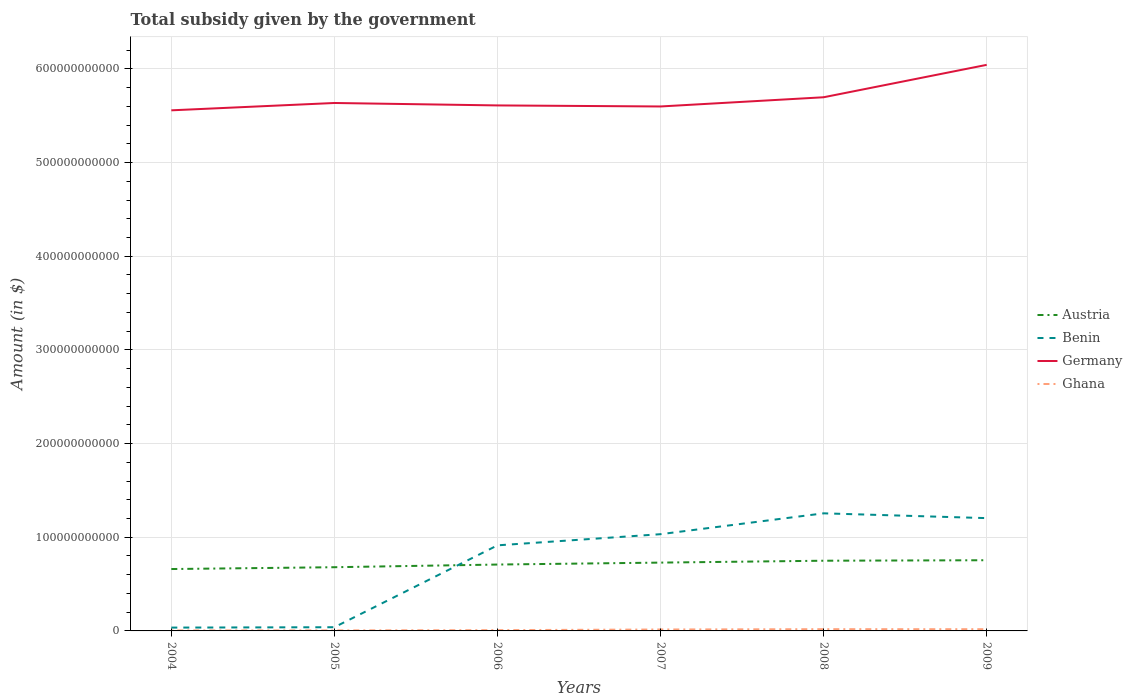How many different coloured lines are there?
Provide a short and direct response. 4. Does the line corresponding to Benin intersect with the line corresponding to Ghana?
Your response must be concise. No. Across all years, what is the maximum total revenue collected by the government in Austria?
Provide a short and direct response. 6.61e+1. In which year was the total revenue collected by the government in Ghana maximum?
Offer a very short reply. 2004. What is the total total revenue collected by the government in Ghana in the graph?
Make the answer very short. -3.14e+08. What is the difference between the highest and the second highest total revenue collected by the government in Benin?
Ensure brevity in your answer.  1.22e+11. Is the total revenue collected by the government in Austria strictly greater than the total revenue collected by the government in Ghana over the years?
Give a very brief answer. No. How many lines are there?
Offer a terse response. 4. How many years are there in the graph?
Ensure brevity in your answer.  6. What is the difference between two consecutive major ticks on the Y-axis?
Your answer should be compact. 1.00e+11. Does the graph contain any zero values?
Ensure brevity in your answer.  No. How many legend labels are there?
Your response must be concise. 4. How are the legend labels stacked?
Your answer should be compact. Vertical. What is the title of the graph?
Give a very brief answer. Total subsidy given by the government. What is the label or title of the Y-axis?
Ensure brevity in your answer.  Amount (in $). What is the Amount (in $) of Austria in 2004?
Provide a short and direct response. 6.61e+1. What is the Amount (in $) of Benin in 2004?
Your answer should be very brief. 3.55e+09. What is the Amount (in $) in Germany in 2004?
Your response must be concise. 5.56e+11. What is the Amount (in $) in Ghana in 2004?
Your answer should be compact. 5.37e+08. What is the Amount (in $) of Austria in 2005?
Your response must be concise. 6.80e+1. What is the Amount (in $) of Benin in 2005?
Provide a succinct answer. 3.96e+09. What is the Amount (in $) of Germany in 2005?
Keep it short and to the point. 5.64e+11. What is the Amount (in $) of Ghana in 2005?
Your answer should be very brief. 5.64e+08. What is the Amount (in $) in Austria in 2006?
Provide a short and direct response. 7.09e+1. What is the Amount (in $) of Benin in 2006?
Your response must be concise. 9.14e+1. What is the Amount (in $) of Germany in 2006?
Offer a terse response. 5.61e+11. What is the Amount (in $) of Ghana in 2006?
Keep it short and to the point. 8.37e+08. What is the Amount (in $) in Austria in 2007?
Provide a short and direct response. 7.29e+1. What is the Amount (in $) of Benin in 2007?
Ensure brevity in your answer.  1.03e+11. What is the Amount (in $) of Germany in 2007?
Your answer should be very brief. 5.60e+11. What is the Amount (in $) in Ghana in 2007?
Your answer should be compact. 1.53e+09. What is the Amount (in $) of Austria in 2008?
Offer a terse response. 7.49e+1. What is the Amount (in $) of Benin in 2008?
Provide a succinct answer. 1.26e+11. What is the Amount (in $) of Germany in 2008?
Offer a terse response. 5.70e+11. What is the Amount (in $) in Ghana in 2008?
Offer a very short reply. 1.87e+09. What is the Amount (in $) of Austria in 2009?
Provide a short and direct response. 7.55e+1. What is the Amount (in $) in Benin in 2009?
Your answer should be compact. 1.20e+11. What is the Amount (in $) in Germany in 2009?
Ensure brevity in your answer.  6.04e+11. What is the Amount (in $) of Ghana in 2009?
Give a very brief answer. 1.84e+09. Across all years, what is the maximum Amount (in $) in Austria?
Your response must be concise. 7.55e+1. Across all years, what is the maximum Amount (in $) of Benin?
Provide a short and direct response. 1.26e+11. Across all years, what is the maximum Amount (in $) in Germany?
Offer a terse response. 6.04e+11. Across all years, what is the maximum Amount (in $) in Ghana?
Give a very brief answer. 1.87e+09. Across all years, what is the minimum Amount (in $) in Austria?
Your answer should be compact. 6.61e+1. Across all years, what is the minimum Amount (in $) of Benin?
Keep it short and to the point. 3.55e+09. Across all years, what is the minimum Amount (in $) in Germany?
Give a very brief answer. 5.56e+11. Across all years, what is the minimum Amount (in $) in Ghana?
Keep it short and to the point. 5.37e+08. What is the total Amount (in $) in Austria in the graph?
Provide a short and direct response. 4.28e+11. What is the total Amount (in $) in Benin in the graph?
Provide a short and direct response. 4.48e+11. What is the total Amount (in $) in Germany in the graph?
Provide a succinct answer. 3.41e+12. What is the total Amount (in $) in Ghana in the graph?
Offer a terse response. 7.18e+09. What is the difference between the Amount (in $) of Austria in 2004 and that in 2005?
Provide a succinct answer. -1.95e+09. What is the difference between the Amount (in $) of Benin in 2004 and that in 2005?
Give a very brief answer. -4.04e+08. What is the difference between the Amount (in $) in Germany in 2004 and that in 2005?
Give a very brief answer. -7.84e+09. What is the difference between the Amount (in $) of Ghana in 2004 and that in 2005?
Make the answer very short. -2.71e+07. What is the difference between the Amount (in $) in Austria in 2004 and that in 2006?
Your answer should be very brief. -4.79e+09. What is the difference between the Amount (in $) of Benin in 2004 and that in 2006?
Ensure brevity in your answer.  -8.78e+1. What is the difference between the Amount (in $) in Germany in 2004 and that in 2006?
Keep it short and to the point. -5.24e+09. What is the difference between the Amount (in $) in Ghana in 2004 and that in 2006?
Make the answer very short. -3.00e+08. What is the difference between the Amount (in $) in Austria in 2004 and that in 2007?
Give a very brief answer. -6.87e+09. What is the difference between the Amount (in $) of Benin in 2004 and that in 2007?
Offer a very short reply. -9.97e+1. What is the difference between the Amount (in $) in Germany in 2004 and that in 2007?
Provide a succinct answer. -4.12e+09. What is the difference between the Amount (in $) of Ghana in 2004 and that in 2007?
Your response must be concise. -9.92e+08. What is the difference between the Amount (in $) of Austria in 2004 and that in 2008?
Offer a very short reply. -8.87e+09. What is the difference between the Amount (in $) of Benin in 2004 and that in 2008?
Offer a very short reply. -1.22e+11. What is the difference between the Amount (in $) of Germany in 2004 and that in 2008?
Ensure brevity in your answer.  -1.40e+1. What is the difference between the Amount (in $) in Ghana in 2004 and that in 2008?
Make the answer very short. -1.33e+09. What is the difference between the Amount (in $) of Austria in 2004 and that in 2009?
Offer a very short reply. -9.40e+09. What is the difference between the Amount (in $) in Benin in 2004 and that in 2009?
Provide a short and direct response. -1.17e+11. What is the difference between the Amount (in $) in Germany in 2004 and that in 2009?
Provide a succinct answer. -4.85e+1. What is the difference between the Amount (in $) in Ghana in 2004 and that in 2009?
Your answer should be very brief. -1.31e+09. What is the difference between the Amount (in $) in Austria in 2005 and that in 2006?
Provide a succinct answer. -2.85e+09. What is the difference between the Amount (in $) of Benin in 2005 and that in 2006?
Your answer should be compact. -8.74e+1. What is the difference between the Amount (in $) in Germany in 2005 and that in 2006?
Give a very brief answer. 2.60e+09. What is the difference between the Amount (in $) of Ghana in 2005 and that in 2006?
Make the answer very short. -2.73e+08. What is the difference between the Amount (in $) of Austria in 2005 and that in 2007?
Your answer should be compact. -4.92e+09. What is the difference between the Amount (in $) in Benin in 2005 and that in 2007?
Offer a very short reply. -9.93e+1. What is the difference between the Amount (in $) in Germany in 2005 and that in 2007?
Ensure brevity in your answer.  3.72e+09. What is the difference between the Amount (in $) of Ghana in 2005 and that in 2007?
Your answer should be compact. -9.65e+08. What is the difference between the Amount (in $) in Austria in 2005 and that in 2008?
Provide a succinct answer. -6.93e+09. What is the difference between the Amount (in $) in Benin in 2005 and that in 2008?
Provide a short and direct response. -1.22e+11. What is the difference between the Amount (in $) of Germany in 2005 and that in 2008?
Provide a succinct answer. -6.11e+09. What is the difference between the Amount (in $) in Ghana in 2005 and that in 2008?
Provide a short and direct response. -1.31e+09. What is the difference between the Amount (in $) of Austria in 2005 and that in 2009?
Your response must be concise. -7.45e+09. What is the difference between the Amount (in $) in Benin in 2005 and that in 2009?
Provide a succinct answer. -1.16e+11. What is the difference between the Amount (in $) of Germany in 2005 and that in 2009?
Your answer should be compact. -4.07e+1. What is the difference between the Amount (in $) of Ghana in 2005 and that in 2009?
Your answer should be compact. -1.28e+09. What is the difference between the Amount (in $) of Austria in 2006 and that in 2007?
Ensure brevity in your answer.  -2.08e+09. What is the difference between the Amount (in $) of Benin in 2006 and that in 2007?
Keep it short and to the point. -1.19e+1. What is the difference between the Amount (in $) of Germany in 2006 and that in 2007?
Your answer should be very brief. 1.12e+09. What is the difference between the Amount (in $) in Ghana in 2006 and that in 2007?
Ensure brevity in your answer.  -6.92e+08. What is the difference between the Amount (in $) of Austria in 2006 and that in 2008?
Make the answer very short. -4.08e+09. What is the difference between the Amount (in $) in Benin in 2006 and that in 2008?
Your response must be concise. -3.42e+1. What is the difference between the Amount (in $) in Germany in 2006 and that in 2008?
Give a very brief answer. -8.71e+09. What is the difference between the Amount (in $) in Ghana in 2006 and that in 2008?
Provide a succinct answer. -1.03e+09. What is the difference between the Amount (in $) in Austria in 2006 and that in 2009?
Offer a terse response. -4.61e+09. What is the difference between the Amount (in $) of Benin in 2006 and that in 2009?
Offer a terse response. -2.91e+1. What is the difference between the Amount (in $) in Germany in 2006 and that in 2009?
Ensure brevity in your answer.  -4.33e+1. What is the difference between the Amount (in $) of Ghana in 2006 and that in 2009?
Provide a succinct answer. -1.01e+09. What is the difference between the Amount (in $) of Austria in 2007 and that in 2008?
Ensure brevity in your answer.  -2.01e+09. What is the difference between the Amount (in $) in Benin in 2007 and that in 2008?
Offer a terse response. -2.23e+1. What is the difference between the Amount (in $) in Germany in 2007 and that in 2008?
Ensure brevity in your answer.  -9.83e+09. What is the difference between the Amount (in $) of Ghana in 2007 and that in 2008?
Provide a succinct answer. -3.43e+08. What is the difference between the Amount (in $) of Austria in 2007 and that in 2009?
Your response must be concise. -2.53e+09. What is the difference between the Amount (in $) in Benin in 2007 and that in 2009?
Provide a short and direct response. -1.71e+1. What is the difference between the Amount (in $) in Germany in 2007 and that in 2009?
Provide a short and direct response. -4.44e+1. What is the difference between the Amount (in $) of Ghana in 2007 and that in 2009?
Your answer should be very brief. -3.14e+08. What is the difference between the Amount (in $) in Austria in 2008 and that in 2009?
Your response must be concise. -5.25e+08. What is the difference between the Amount (in $) of Benin in 2008 and that in 2009?
Your answer should be compact. 5.12e+09. What is the difference between the Amount (in $) in Germany in 2008 and that in 2009?
Your answer should be very brief. -3.46e+1. What is the difference between the Amount (in $) in Ghana in 2008 and that in 2009?
Your answer should be compact. 2.92e+07. What is the difference between the Amount (in $) in Austria in 2004 and the Amount (in $) in Benin in 2005?
Your answer should be compact. 6.21e+1. What is the difference between the Amount (in $) in Austria in 2004 and the Amount (in $) in Germany in 2005?
Provide a succinct answer. -4.98e+11. What is the difference between the Amount (in $) of Austria in 2004 and the Amount (in $) of Ghana in 2005?
Offer a very short reply. 6.55e+1. What is the difference between the Amount (in $) in Benin in 2004 and the Amount (in $) in Germany in 2005?
Make the answer very short. -5.60e+11. What is the difference between the Amount (in $) of Benin in 2004 and the Amount (in $) of Ghana in 2005?
Ensure brevity in your answer.  2.99e+09. What is the difference between the Amount (in $) in Germany in 2004 and the Amount (in $) in Ghana in 2005?
Make the answer very short. 5.55e+11. What is the difference between the Amount (in $) in Austria in 2004 and the Amount (in $) in Benin in 2006?
Provide a short and direct response. -2.53e+1. What is the difference between the Amount (in $) of Austria in 2004 and the Amount (in $) of Germany in 2006?
Ensure brevity in your answer.  -4.95e+11. What is the difference between the Amount (in $) in Austria in 2004 and the Amount (in $) in Ghana in 2006?
Your response must be concise. 6.52e+1. What is the difference between the Amount (in $) in Benin in 2004 and the Amount (in $) in Germany in 2006?
Your response must be concise. -5.57e+11. What is the difference between the Amount (in $) in Benin in 2004 and the Amount (in $) in Ghana in 2006?
Offer a terse response. 2.72e+09. What is the difference between the Amount (in $) in Germany in 2004 and the Amount (in $) in Ghana in 2006?
Offer a terse response. 5.55e+11. What is the difference between the Amount (in $) in Austria in 2004 and the Amount (in $) in Benin in 2007?
Make the answer very short. -3.72e+1. What is the difference between the Amount (in $) in Austria in 2004 and the Amount (in $) in Germany in 2007?
Offer a terse response. -4.94e+11. What is the difference between the Amount (in $) of Austria in 2004 and the Amount (in $) of Ghana in 2007?
Give a very brief answer. 6.45e+1. What is the difference between the Amount (in $) in Benin in 2004 and the Amount (in $) in Germany in 2007?
Give a very brief answer. -5.56e+11. What is the difference between the Amount (in $) in Benin in 2004 and the Amount (in $) in Ghana in 2007?
Keep it short and to the point. 2.02e+09. What is the difference between the Amount (in $) of Germany in 2004 and the Amount (in $) of Ghana in 2007?
Give a very brief answer. 5.54e+11. What is the difference between the Amount (in $) in Austria in 2004 and the Amount (in $) in Benin in 2008?
Your answer should be compact. -5.95e+1. What is the difference between the Amount (in $) in Austria in 2004 and the Amount (in $) in Germany in 2008?
Keep it short and to the point. -5.04e+11. What is the difference between the Amount (in $) in Austria in 2004 and the Amount (in $) in Ghana in 2008?
Keep it short and to the point. 6.42e+1. What is the difference between the Amount (in $) in Benin in 2004 and the Amount (in $) in Germany in 2008?
Offer a terse response. -5.66e+11. What is the difference between the Amount (in $) of Benin in 2004 and the Amount (in $) of Ghana in 2008?
Provide a succinct answer. 1.68e+09. What is the difference between the Amount (in $) in Germany in 2004 and the Amount (in $) in Ghana in 2008?
Give a very brief answer. 5.54e+11. What is the difference between the Amount (in $) of Austria in 2004 and the Amount (in $) of Benin in 2009?
Your answer should be very brief. -5.43e+1. What is the difference between the Amount (in $) in Austria in 2004 and the Amount (in $) in Germany in 2009?
Ensure brevity in your answer.  -5.38e+11. What is the difference between the Amount (in $) in Austria in 2004 and the Amount (in $) in Ghana in 2009?
Your response must be concise. 6.42e+1. What is the difference between the Amount (in $) of Benin in 2004 and the Amount (in $) of Germany in 2009?
Your answer should be compact. -6.01e+11. What is the difference between the Amount (in $) in Benin in 2004 and the Amount (in $) in Ghana in 2009?
Provide a short and direct response. 1.71e+09. What is the difference between the Amount (in $) of Germany in 2004 and the Amount (in $) of Ghana in 2009?
Provide a succinct answer. 5.54e+11. What is the difference between the Amount (in $) in Austria in 2005 and the Amount (in $) in Benin in 2006?
Your answer should be compact. -2.33e+1. What is the difference between the Amount (in $) of Austria in 2005 and the Amount (in $) of Germany in 2006?
Ensure brevity in your answer.  -4.93e+11. What is the difference between the Amount (in $) in Austria in 2005 and the Amount (in $) in Ghana in 2006?
Your answer should be compact. 6.72e+1. What is the difference between the Amount (in $) in Benin in 2005 and the Amount (in $) in Germany in 2006?
Make the answer very short. -5.57e+11. What is the difference between the Amount (in $) of Benin in 2005 and the Amount (in $) of Ghana in 2006?
Your answer should be very brief. 3.12e+09. What is the difference between the Amount (in $) in Germany in 2005 and the Amount (in $) in Ghana in 2006?
Provide a succinct answer. 5.63e+11. What is the difference between the Amount (in $) of Austria in 2005 and the Amount (in $) of Benin in 2007?
Give a very brief answer. -3.53e+1. What is the difference between the Amount (in $) of Austria in 2005 and the Amount (in $) of Germany in 2007?
Offer a terse response. -4.92e+11. What is the difference between the Amount (in $) of Austria in 2005 and the Amount (in $) of Ghana in 2007?
Ensure brevity in your answer.  6.65e+1. What is the difference between the Amount (in $) in Benin in 2005 and the Amount (in $) in Germany in 2007?
Provide a succinct answer. -5.56e+11. What is the difference between the Amount (in $) in Benin in 2005 and the Amount (in $) in Ghana in 2007?
Offer a terse response. 2.43e+09. What is the difference between the Amount (in $) in Germany in 2005 and the Amount (in $) in Ghana in 2007?
Offer a terse response. 5.62e+11. What is the difference between the Amount (in $) in Austria in 2005 and the Amount (in $) in Benin in 2008?
Ensure brevity in your answer.  -5.75e+1. What is the difference between the Amount (in $) of Austria in 2005 and the Amount (in $) of Germany in 2008?
Provide a short and direct response. -5.02e+11. What is the difference between the Amount (in $) of Austria in 2005 and the Amount (in $) of Ghana in 2008?
Ensure brevity in your answer.  6.61e+1. What is the difference between the Amount (in $) in Benin in 2005 and the Amount (in $) in Germany in 2008?
Your answer should be very brief. -5.66e+11. What is the difference between the Amount (in $) in Benin in 2005 and the Amount (in $) in Ghana in 2008?
Offer a terse response. 2.08e+09. What is the difference between the Amount (in $) in Germany in 2005 and the Amount (in $) in Ghana in 2008?
Give a very brief answer. 5.62e+11. What is the difference between the Amount (in $) of Austria in 2005 and the Amount (in $) of Benin in 2009?
Your answer should be compact. -5.24e+1. What is the difference between the Amount (in $) of Austria in 2005 and the Amount (in $) of Germany in 2009?
Offer a terse response. -5.36e+11. What is the difference between the Amount (in $) of Austria in 2005 and the Amount (in $) of Ghana in 2009?
Your answer should be compact. 6.62e+1. What is the difference between the Amount (in $) of Benin in 2005 and the Amount (in $) of Germany in 2009?
Provide a short and direct response. -6.00e+11. What is the difference between the Amount (in $) of Benin in 2005 and the Amount (in $) of Ghana in 2009?
Give a very brief answer. 2.11e+09. What is the difference between the Amount (in $) in Germany in 2005 and the Amount (in $) in Ghana in 2009?
Provide a succinct answer. 5.62e+11. What is the difference between the Amount (in $) of Austria in 2006 and the Amount (in $) of Benin in 2007?
Make the answer very short. -3.24e+1. What is the difference between the Amount (in $) in Austria in 2006 and the Amount (in $) in Germany in 2007?
Offer a terse response. -4.89e+11. What is the difference between the Amount (in $) in Austria in 2006 and the Amount (in $) in Ghana in 2007?
Your response must be concise. 6.93e+1. What is the difference between the Amount (in $) in Benin in 2006 and the Amount (in $) in Germany in 2007?
Provide a short and direct response. -4.68e+11. What is the difference between the Amount (in $) in Benin in 2006 and the Amount (in $) in Ghana in 2007?
Make the answer very short. 8.98e+1. What is the difference between the Amount (in $) of Germany in 2006 and the Amount (in $) of Ghana in 2007?
Offer a terse response. 5.59e+11. What is the difference between the Amount (in $) of Austria in 2006 and the Amount (in $) of Benin in 2008?
Your response must be concise. -5.47e+1. What is the difference between the Amount (in $) of Austria in 2006 and the Amount (in $) of Germany in 2008?
Your answer should be very brief. -4.99e+11. What is the difference between the Amount (in $) of Austria in 2006 and the Amount (in $) of Ghana in 2008?
Your response must be concise. 6.90e+1. What is the difference between the Amount (in $) of Benin in 2006 and the Amount (in $) of Germany in 2008?
Offer a terse response. -4.78e+11. What is the difference between the Amount (in $) of Benin in 2006 and the Amount (in $) of Ghana in 2008?
Provide a succinct answer. 8.95e+1. What is the difference between the Amount (in $) in Germany in 2006 and the Amount (in $) in Ghana in 2008?
Provide a succinct answer. 5.59e+11. What is the difference between the Amount (in $) of Austria in 2006 and the Amount (in $) of Benin in 2009?
Your answer should be compact. -4.96e+1. What is the difference between the Amount (in $) in Austria in 2006 and the Amount (in $) in Germany in 2009?
Provide a short and direct response. -5.33e+11. What is the difference between the Amount (in $) of Austria in 2006 and the Amount (in $) of Ghana in 2009?
Give a very brief answer. 6.90e+1. What is the difference between the Amount (in $) of Benin in 2006 and the Amount (in $) of Germany in 2009?
Offer a terse response. -5.13e+11. What is the difference between the Amount (in $) in Benin in 2006 and the Amount (in $) in Ghana in 2009?
Your answer should be compact. 8.95e+1. What is the difference between the Amount (in $) in Germany in 2006 and the Amount (in $) in Ghana in 2009?
Your answer should be very brief. 5.59e+11. What is the difference between the Amount (in $) of Austria in 2007 and the Amount (in $) of Benin in 2008?
Your answer should be very brief. -5.26e+1. What is the difference between the Amount (in $) in Austria in 2007 and the Amount (in $) in Germany in 2008?
Your response must be concise. -4.97e+11. What is the difference between the Amount (in $) of Austria in 2007 and the Amount (in $) of Ghana in 2008?
Make the answer very short. 7.11e+1. What is the difference between the Amount (in $) of Benin in 2007 and the Amount (in $) of Germany in 2008?
Provide a succinct answer. -4.66e+11. What is the difference between the Amount (in $) in Benin in 2007 and the Amount (in $) in Ghana in 2008?
Give a very brief answer. 1.01e+11. What is the difference between the Amount (in $) in Germany in 2007 and the Amount (in $) in Ghana in 2008?
Offer a very short reply. 5.58e+11. What is the difference between the Amount (in $) of Austria in 2007 and the Amount (in $) of Benin in 2009?
Ensure brevity in your answer.  -4.75e+1. What is the difference between the Amount (in $) in Austria in 2007 and the Amount (in $) in Germany in 2009?
Ensure brevity in your answer.  -5.31e+11. What is the difference between the Amount (in $) of Austria in 2007 and the Amount (in $) of Ghana in 2009?
Make the answer very short. 7.11e+1. What is the difference between the Amount (in $) in Benin in 2007 and the Amount (in $) in Germany in 2009?
Provide a short and direct response. -5.01e+11. What is the difference between the Amount (in $) of Benin in 2007 and the Amount (in $) of Ghana in 2009?
Your response must be concise. 1.01e+11. What is the difference between the Amount (in $) of Germany in 2007 and the Amount (in $) of Ghana in 2009?
Give a very brief answer. 5.58e+11. What is the difference between the Amount (in $) in Austria in 2008 and the Amount (in $) in Benin in 2009?
Ensure brevity in your answer.  -4.55e+1. What is the difference between the Amount (in $) of Austria in 2008 and the Amount (in $) of Germany in 2009?
Ensure brevity in your answer.  -5.29e+11. What is the difference between the Amount (in $) in Austria in 2008 and the Amount (in $) in Ghana in 2009?
Offer a terse response. 7.31e+1. What is the difference between the Amount (in $) in Benin in 2008 and the Amount (in $) in Germany in 2009?
Offer a very short reply. -4.79e+11. What is the difference between the Amount (in $) in Benin in 2008 and the Amount (in $) in Ghana in 2009?
Offer a terse response. 1.24e+11. What is the difference between the Amount (in $) in Germany in 2008 and the Amount (in $) in Ghana in 2009?
Provide a short and direct response. 5.68e+11. What is the average Amount (in $) of Austria per year?
Provide a short and direct response. 7.14e+1. What is the average Amount (in $) of Benin per year?
Make the answer very short. 7.47e+1. What is the average Amount (in $) in Germany per year?
Offer a terse response. 5.69e+11. What is the average Amount (in $) of Ghana per year?
Make the answer very short. 1.20e+09. In the year 2004, what is the difference between the Amount (in $) of Austria and Amount (in $) of Benin?
Provide a succinct answer. 6.25e+1. In the year 2004, what is the difference between the Amount (in $) of Austria and Amount (in $) of Germany?
Your answer should be compact. -4.90e+11. In the year 2004, what is the difference between the Amount (in $) in Austria and Amount (in $) in Ghana?
Keep it short and to the point. 6.55e+1. In the year 2004, what is the difference between the Amount (in $) of Benin and Amount (in $) of Germany?
Offer a terse response. -5.52e+11. In the year 2004, what is the difference between the Amount (in $) of Benin and Amount (in $) of Ghana?
Offer a terse response. 3.02e+09. In the year 2004, what is the difference between the Amount (in $) of Germany and Amount (in $) of Ghana?
Make the answer very short. 5.55e+11. In the year 2005, what is the difference between the Amount (in $) in Austria and Amount (in $) in Benin?
Give a very brief answer. 6.41e+1. In the year 2005, what is the difference between the Amount (in $) of Austria and Amount (in $) of Germany?
Your answer should be compact. -4.96e+11. In the year 2005, what is the difference between the Amount (in $) of Austria and Amount (in $) of Ghana?
Provide a succinct answer. 6.74e+1. In the year 2005, what is the difference between the Amount (in $) in Benin and Amount (in $) in Germany?
Your answer should be very brief. -5.60e+11. In the year 2005, what is the difference between the Amount (in $) in Benin and Amount (in $) in Ghana?
Your response must be concise. 3.39e+09. In the year 2005, what is the difference between the Amount (in $) in Germany and Amount (in $) in Ghana?
Offer a very short reply. 5.63e+11. In the year 2006, what is the difference between the Amount (in $) of Austria and Amount (in $) of Benin?
Your answer should be very brief. -2.05e+1. In the year 2006, what is the difference between the Amount (in $) in Austria and Amount (in $) in Germany?
Offer a terse response. -4.90e+11. In the year 2006, what is the difference between the Amount (in $) in Austria and Amount (in $) in Ghana?
Your response must be concise. 7.00e+1. In the year 2006, what is the difference between the Amount (in $) of Benin and Amount (in $) of Germany?
Make the answer very short. -4.70e+11. In the year 2006, what is the difference between the Amount (in $) of Benin and Amount (in $) of Ghana?
Offer a very short reply. 9.05e+1. In the year 2006, what is the difference between the Amount (in $) in Germany and Amount (in $) in Ghana?
Offer a very short reply. 5.60e+11. In the year 2007, what is the difference between the Amount (in $) of Austria and Amount (in $) of Benin?
Ensure brevity in your answer.  -3.03e+1. In the year 2007, what is the difference between the Amount (in $) in Austria and Amount (in $) in Germany?
Offer a very short reply. -4.87e+11. In the year 2007, what is the difference between the Amount (in $) in Austria and Amount (in $) in Ghana?
Make the answer very short. 7.14e+1. In the year 2007, what is the difference between the Amount (in $) of Benin and Amount (in $) of Germany?
Your response must be concise. -4.57e+11. In the year 2007, what is the difference between the Amount (in $) of Benin and Amount (in $) of Ghana?
Your answer should be very brief. 1.02e+11. In the year 2007, what is the difference between the Amount (in $) in Germany and Amount (in $) in Ghana?
Your answer should be compact. 5.58e+11. In the year 2008, what is the difference between the Amount (in $) of Austria and Amount (in $) of Benin?
Keep it short and to the point. -5.06e+1. In the year 2008, what is the difference between the Amount (in $) of Austria and Amount (in $) of Germany?
Your answer should be compact. -4.95e+11. In the year 2008, what is the difference between the Amount (in $) of Austria and Amount (in $) of Ghana?
Ensure brevity in your answer.  7.31e+1. In the year 2008, what is the difference between the Amount (in $) of Benin and Amount (in $) of Germany?
Your answer should be very brief. -4.44e+11. In the year 2008, what is the difference between the Amount (in $) in Benin and Amount (in $) in Ghana?
Your response must be concise. 1.24e+11. In the year 2008, what is the difference between the Amount (in $) in Germany and Amount (in $) in Ghana?
Make the answer very short. 5.68e+11. In the year 2009, what is the difference between the Amount (in $) in Austria and Amount (in $) in Benin?
Keep it short and to the point. -4.49e+1. In the year 2009, what is the difference between the Amount (in $) of Austria and Amount (in $) of Germany?
Your answer should be very brief. -5.29e+11. In the year 2009, what is the difference between the Amount (in $) in Austria and Amount (in $) in Ghana?
Provide a succinct answer. 7.36e+1. In the year 2009, what is the difference between the Amount (in $) in Benin and Amount (in $) in Germany?
Offer a terse response. -4.84e+11. In the year 2009, what is the difference between the Amount (in $) of Benin and Amount (in $) of Ghana?
Ensure brevity in your answer.  1.19e+11. In the year 2009, what is the difference between the Amount (in $) in Germany and Amount (in $) in Ghana?
Your answer should be very brief. 6.02e+11. What is the ratio of the Amount (in $) in Austria in 2004 to that in 2005?
Provide a short and direct response. 0.97. What is the ratio of the Amount (in $) in Benin in 2004 to that in 2005?
Your answer should be very brief. 0.9. What is the ratio of the Amount (in $) in Germany in 2004 to that in 2005?
Provide a short and direct response. 0.99. What is the ratio of the Amount (in $) in Ghana in 2004 to that in 2005?
Your answer should be very brief. 0.95. What is the ratio of the Amount (in $) of Austria in 2004 to that in 2006?
Your answer should be compact. 0.93. What is the ratio of the Amount (in $) in Benin in 2004 to that in 2006?
Your response must be concise. 0.04. What is the ratio of the Amount (in $) in Germany in 2004 to that in 2006?
Offer a terse response. 0.99. What is the ratio of the Amount (in $) in Ghana in 2004 to that in 2006?
Your answer should be very brief. 0.64. What is the ratio of the Amount (in $) in Austria in 2004 to that in 2007?
Your answer should be compact. 0.91. What is the ratio of the Amount (in $) in Benin in 2004 to that in 2007?
Your response must be concise. 0.03. What is the ratio of the Amount (in $) of Ghana in 2004 to that in 2007?
Your response must be concise. 0.35. What is the ratio of the Amount (in $) in Austria in 2004 to that in 2008?
Keep it short and to the point. 0.88. What is the ratio of the Amount (in $) in Benin in 2004 to that in 2008?
Ensure brevity in your answer.  0.03. What is the ratio of the Amount (in $) of Germany in 2004 to that in 2008?
Keep it short and to the point. 0.98. What is the ratio of the Amount (in $) of Ghana in 2004 to that in 2008?
Ensure brevity in your answer.  0.29. What is the ratio of the Amount (in $) of Austria in 2004 to that in 2009?
Provide a short and direct response. 0.88. What is the ratio of the Amount (in $) of Benin in 2004 to that in 2009?
Your answer should be very brief. 0.03. What is the ratio of the Amount (in $) in Germany in 2004 to that in 2009?
Provide a short and direct response. 0.92. What is the ratio of the Amount (in $) of Ghana in 2004 to that in 2009?
Make the answer very short. 0.29. What is the ratio of the Amount (in $) in Austria in 2005 to that in 2006?
Ensure brevity in your answer.  0.96. What is the ratio of the Amount (in $) of Benin in 2005 to that in 2006?
Provide a succinct answer. 0.04. What is the ratio of the Amount (in $) in Ghana in 2005 to that in 2006?
Provide a short and direct response. 0.67. What is the ratio of the Amount (in $) in Austria in 2005 to that in 2007?
Keep it short and to the point. 0.93. What is the ratio of the Amount (in $) of Benin in 2005 to that in 2007?
Ensure brevity in your answer.  0.04. What is the ratio of the Amount (in $) of Germany in 2005 to that in 2007?
Make the answer very short. 1.01. What is the ratio of the Amount (in $) of Ghana in 2005 to that in 2007?
Give a very brief answer. 0.37. What is the ratio of the Amount (in $) of Austria in 2005 to that in 2008?
Offer a terse response. 0.91. What is the ratio of the Amount (in $) of Benin in 2005 to that in 2008?
Offer a terse response. 0.03. What is the ratio of the Amount (in $) of Germany in 2005 to that in 2008?
Your answer should be very brief. 0.99. What is the ratio of the Amount (in $) in Ghana in 2005 to that in 2008?
Offer a very short reply. 0.3. What is the ratio of the Amount (in $) in Austria in 2005 to that in 2009?
Your answer should be compact. 0.9. What is the ratio of the Amount (in $) in Benin in 2005 to that in 2009?
Your response must be concise. 0.03. What is the ratio of the Amount (in $) in Germany in 2005 to that in 2009?
Ensure brevity in your answer.  0.93. What is the ratio of the Amount (in $) of Ghana in 2005 to that in 2009?
Provide a short and direct response. 0.31. What is the ratio of the Amount (in $) of Austria in 2006 to that in 2007?
Make the answer very short. 0.97. What is the ratio of the Amount (in $) of Benin in 2006 to that in 2007?
Ensure brevity in your answer.  0.88. What is the ratio of the Amount (in $) in Germany in 2006 to that in 2007?
Your answer should be compact. 1. What is the ratio of the Amount (in $) of Ghana in 2006 to that in 2007?
Offer a very short reply. 0.55. What is the ratio of the Amount (in $) in Austria in 2006 to that in 2008?
Your answer should be compact. 0.95. What is the ratio of the Amount (in $) in Benin in 2006 to that in 2008?
Provide a succinct answer. 0.73. What is the ratio of the Amount (in $) of Germany in 2006 to that in 2008?
Give a very brief answer. 0.98. What is the ratio of the Amount (in $) of Ghana in 2006 to that in 2008?
Your response must be concise. 0.45. What is the ratio of the Amount (in $) of Austria in 2006 to that in 2009?
Provide a succinct answer. 0.94. What is the ratio of the Amount (in $) in Benin in 2006 to that in 2009?
Offer a terse response. 0.76. What is the ratio of the Amount (in $) in Germany in 2006 to that in 2009?
Offer a very short reply. 0.93. What is the ratio of the Amount (in $) in Ghana in 2006 to that in 2009?
Offer a terse response. 0.45. What is the ratio of the Amount (in $) in Austria in 2007 to that in 2008?
Your answer should be very brief. 0.97. What is the ratio of the Amount (in $) in Benin in 2007 to that in 2008?
Your response must be concise. 0.82. What is the ratio of the Amount (in $) in Germany in 2007 to that in 2008?
Your answer should be very brief. 0.98. What is the ratio of the Amount (in $) in Ghana in 2007 to that in 2008?
Keep it short and to the point. 0.82. What is the ratio of the Amount (in $) of Austria in 2007 to that in 2009?
Provide a succinct answer. 0.97. What is the ratio of the Amount (in $) of Benin in 2007 to that in 2009?
Offer a very short reply. 0.86. What is the ratio of the Amount (in $) of Germany in 2007 to that in 2009?
Keep it short and to the point. 0.93. What is the ratio of the Amount (in $) of Ghana in 2007 to that in 2009?
Offer a terse response. 0.83. What is the ratio of the Amount (in $) of Austria in 2008 to that in 2009?
Offer a terse response. 0.99. What is the ratio of the Amount (in $) of Benin in 2008 to that in 2009?
Offer a very short reply. 1.04. What is the ratio of the Amount (in $) in Germany in 2008 to that in 2009?
Offer a terse response. 0.94. What is the ratio of the Amount (in $) of Ghana in 2008 to that in 2009?
Make the answer very short. 1.02. What is the difference between the highest and the second highest Amount (in $) of Austria?
Your answer should be very brief. 5.25e+08. What is the difference between the highest and the second highest Amount (in $) of Benin?
Your answer should be very brief. 5.12e+09. What is the difference between the highest and the second highest Amount (in $) of Germany?
Your answer should be very brief. 3.46e+1. What is the difference between the highest and the second highest Amount (in $) of Ghana?
Give a very brief answer. 2.92e+07. What is the difference between the highest and the lowest Amount (in $) of Austria?
Offer a terse response. 9.40e+09. What is the difference between the highest and the lowest Amount (in $) in Benin?
Ensure brevity in your answer.  1.22e+11. What is the difference between the highest and the lowest Amount (in $) of Germany?
Your answer should be compact. 4.85e+1. What is the difference between the highest and the lowest Amount (in $) in Ghana?
Your answer should be very brief. 1.33e+09. 